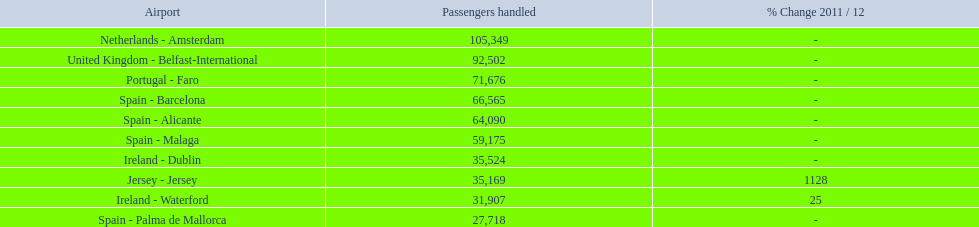How many passengers did the united kingdom handle? 92,502. Who handled more passengers than this? Netherlands - Amsterdam. What are all of the airports? Netherlands - Amsterdam, United Kingdom - Belfast-International, Portugal - Faro, Spain - Barcelona, Spain - Alicante, Spain - Malaga, Ireland - Dublin, Jersey - Jersey, Ireland - Waterford, Spain - Palma de Mallorca. How many passengers have they handled? 105,349, 92,502, 71,676, 66,565, 64,090, 59,175, 35,524, 35,169, 31,907, 27,718. And which airport has handled the most passengers? Netherlands - Amsterdam. 